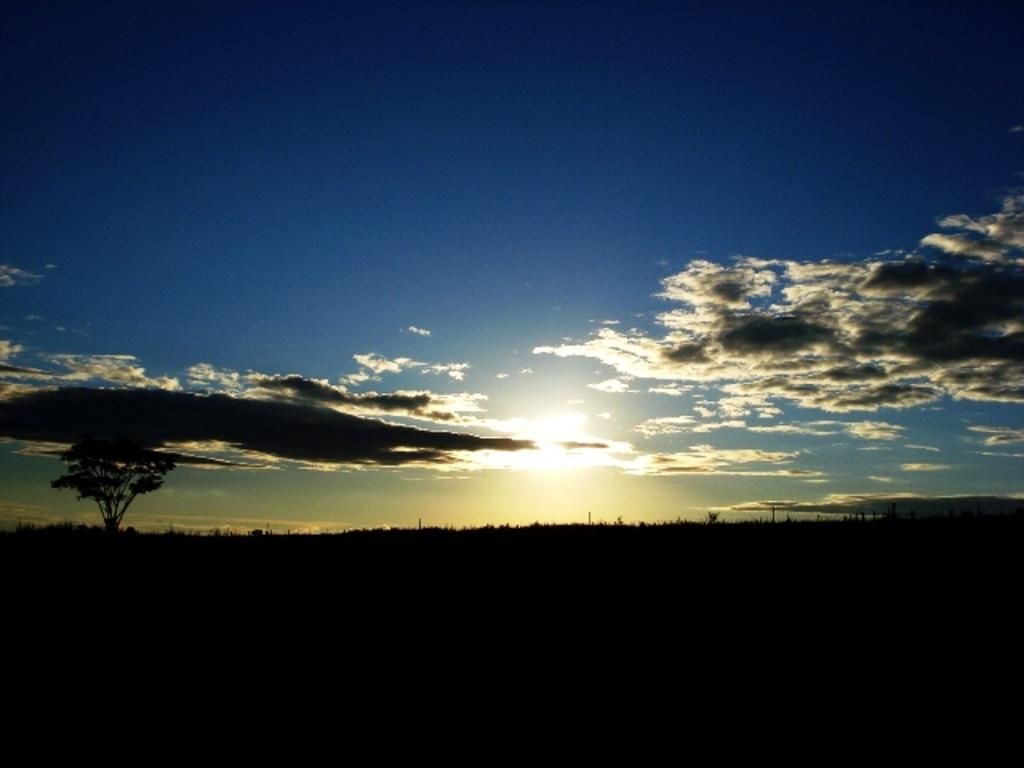What type of natural environment is visible at the bottom of the image? There is greenery at the bottom side of the image. What part of the natural environment is visible in the center of the image? There is sky visible in the center of the image. How many matches are present in the image? There are no matches visible in the image. What type of vegetable can be seen growing in the greenery at the bottom of the image? There is no vegetable visible in the greenery at the bottom of the image. 